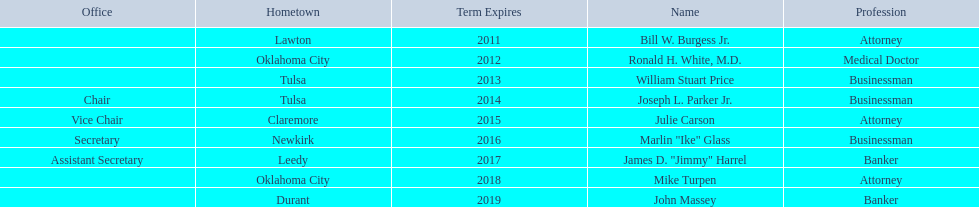What businessmen were born in tulsa? William Stuart Price, Joseph L. Parker Jr. Which man, other than price, was born in tulsa? Joseph L. Parker Jr. 